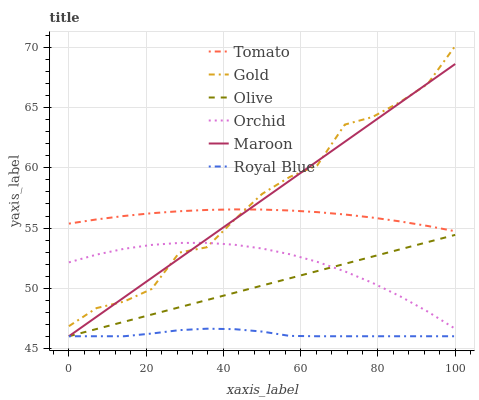Does Royal Blue have the minimum area under the curve?
Answer yes or no. Yes. Does Gold have the maximum area under the curve?
Answer yes or no. Yes. Does Maroon have the minimum area under the curve?
Answer yes or no. No. Does Maroon have the maximum area under the curve?
Answer yes or no. No. Is Olive the smoothest?
Answer yes or no. Yes. Is Gold the roughest?
Answer yes or no. Yes. Is Maroon the smoothest?
Answer yes or no. No. Is Maroon the roughest?
Answer yes or no. No. Does Maroon have the lowest value?
Answer yes or no. Yes. Does Gold have the lowest value?
Answer yes or no. No. Does Gold have the highest value?
Answer yes or no. Yes. Does Maroon have the highest value?
Answer yes or no. No. Is Orchid less than Tomato?
Answer yes or no. Yes. Is Tomato greater than Orchid?
Answer yes or no. Yes. Does Maroon intersect Gold?
Answer yes or no. Yes. Is Maroon less than Gold?
Answer yes or no. No. Is Maroon greater than Gold?
Answer yes or no. No. Does Orchid intersect Tomato?
Answer yes or no. No. 